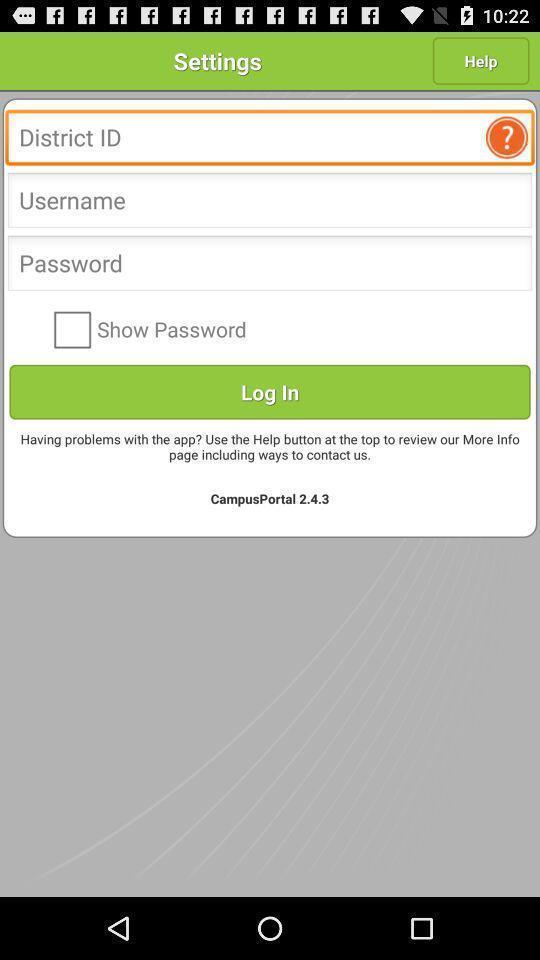What can you discern from this picture? Page displaying options to login. 